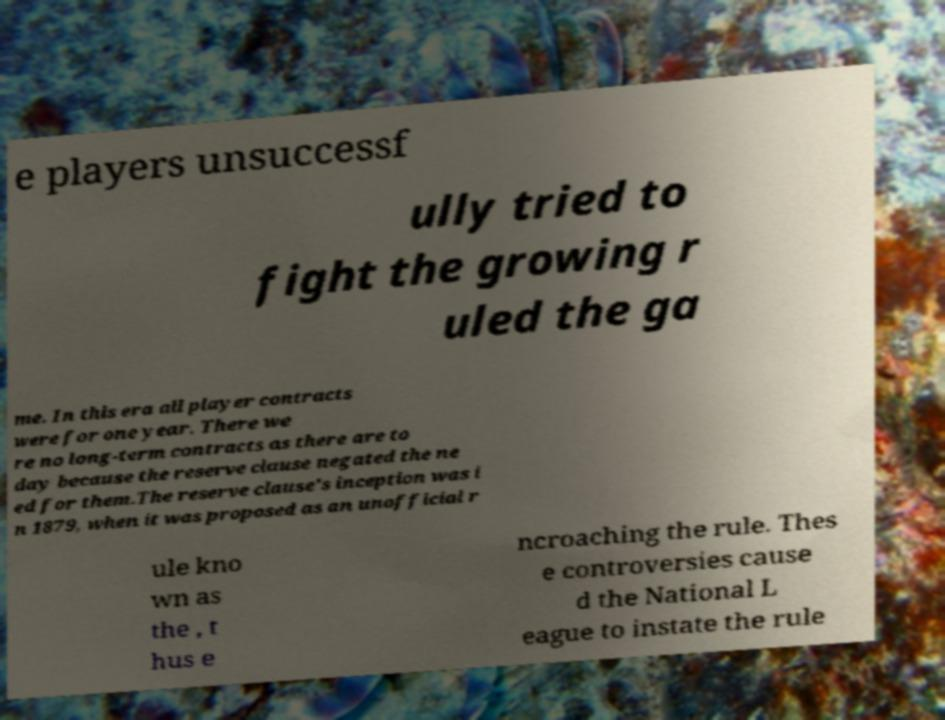Please read and relay the text visible in this image. What does it say? e players unsuccessf ully tried to fight the growing r uled the ga me. In this era all player contracts were for one year. There we re no long-term contracts as there are to day because the reserve clause negated the ne ed for them.The reserve clause's inception was i n 1879, when it was proposed as an unofficial r ule kno wn as the , t hus e ncroaching the rule. Thes e controversies cause d the National L eague to instate the rule 